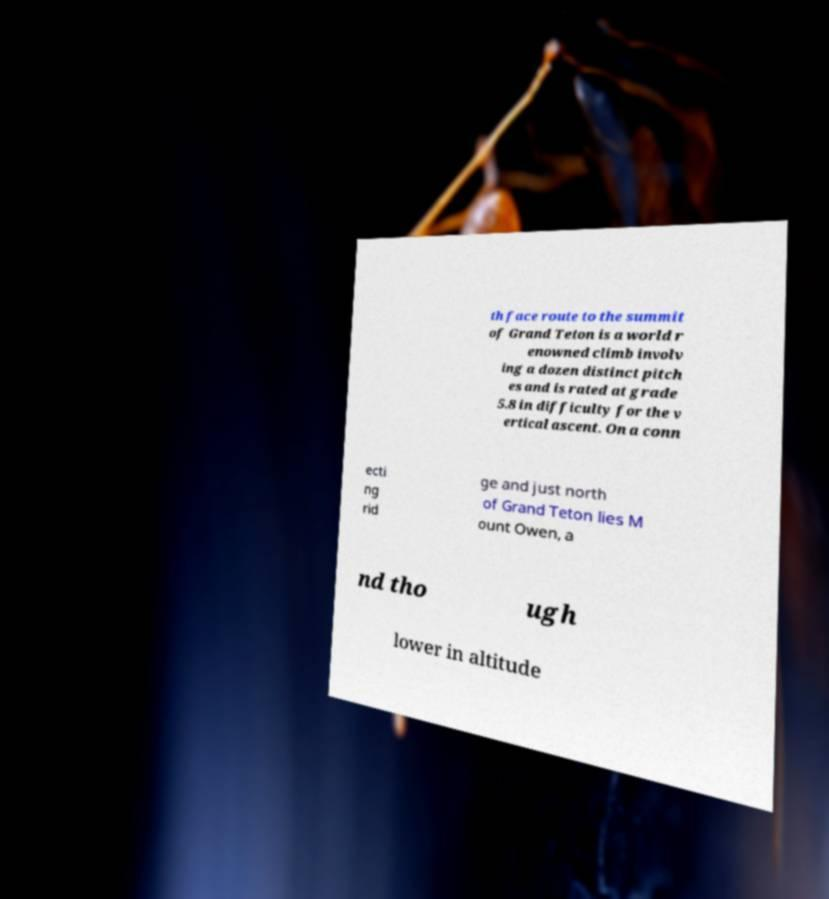For documentation purposes, I need the text within this image transcribed. Could you provide that? th face route to the summit of Grand Teton is a world r enowned climb involv ing a dozen distinct pitch es and is rated at grade 5.8 in difficulty for the v ertical ascent. On a conn ecti ng rid ge and just north of Grand Teton lies M ount Owen, a nd tho ugh lower in altitude 